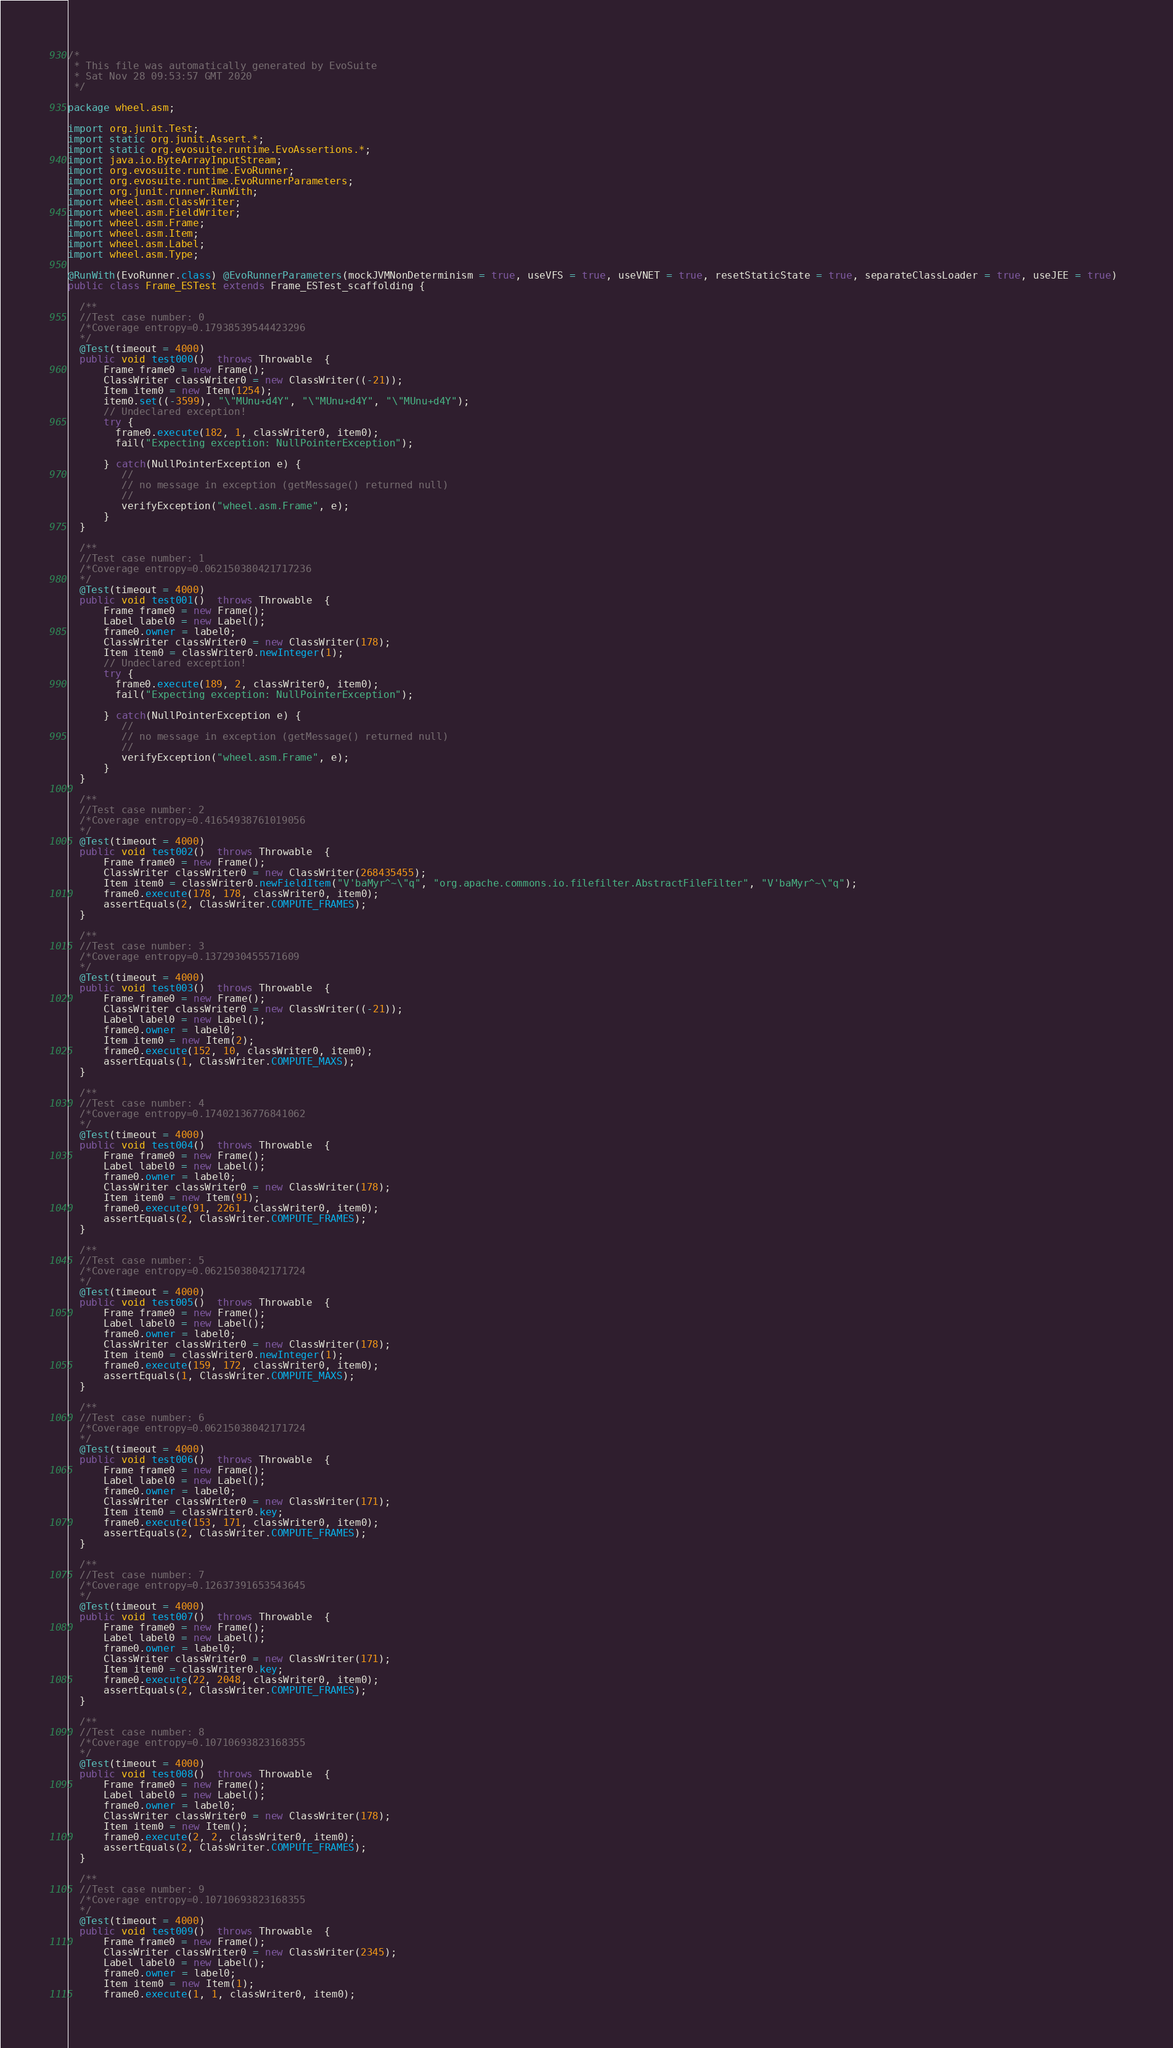<code> <loc_0><loc_0><loc_500><loc_500><_Java_>/*
 * This file was automatically generated by EvoSuite
 * Sat Nov 28 09:53:57 GMT 2020
 */

package wheel.asm;

import org.junit.Test;
import static org.junit.Assert.*;
import static org.evosuite.runtime.EvoAssertions.*;
import java.io.ByteArrayInputStream;
import org.evosuite.runtime.EvoRunner;
import org.evosuite.runtime.EvoRunnerParameters;
import org.junit.runner.RunWith;
import wheel.asm.ClassWriter;
import wheel.asm.FieldWriter;
import wheel.asm.Frame;
import wheel.asm.Item;
import wheel.asm.Label;
import wheel.asm.Type;

@RunWith(EvoRunner.class) @EvoRunnerParameters(mockJVMNonDeterminism = true, useVFS = true, useVNET = true, resetStaticState = true, separateClassLoader = true, useJEE = true) 
public class Frame_ESTest extends Frame_ESTest_scaffolding {

  /**
  //Test case number: 0
  /*Coverage entropy=0.17938539544423296
  */
  @Test(timeout = 4000)
  public void test000()  throws Throwable  {
      Frame frame0 = new Frame();
      ClassWriter classWriter0 = new ClassWriter((-21));
      Item item0 = new Item(1254);
      item0.set((-3599), "\"MUnu+d4Y", "\"MUnu+d4Y", "\"MUnu+d4Y");
      // Undeclared exception!
      try { 
        frame0.execute(182, 1, classWriter0, item0);
        fail("Expecting exception: NullPointerException");
      
      } catch(NullPointerException e) {
         //
         // no message in exception (getMessage() returned null)
         //
         verifyException("wheel.asm.Frame", e);
      }
  }

  /**
  //Test case number: 1
  /*Coverage entropy=0.062150380421717236
  */
  @Test(timeout = 4000)
  public void test001()  throws Throwable  {
      Frame frame0 = new Frame();
      Label label0 = new Label();
      frame0.owner = label0;
      ClassWriter classWriter0 = new ClassWriter(178);
      Item item0 = classWriter0.newInteger(1);
      // Undeclared exception!
      try { 
        frame0.execute(189, 2, classWriter0, item0);
        fail("Expecting exception: NullPointerException");
      
      } catch(NullPointerException e) {
         //
         // no message in exception (getMessage() returned null)
         //
         verifyException("wheel.asm.Frame", e);
      }
  }

  /**
  //Test case number: 2
  /*Coverage entropy=0.41654938761019056
  */
  @Test(timeout = 4000)
  public void test002()  throws Throwable  {
      Frame frame0 = new Frame();
      ClassWriter classWriter0 = new ClassWriter(268435455);
      Item item0 = classWriter0.newFieldItem("V'baMyr^~\"q", "org.apache.commons.io.filefilter.AbstractFileFilter", "V'baMyr^~\"q");
      frame0.execute(178, 178, classWriter0, item0);
      assertEquals(2, ClassWriter.COMPUTE_FRAMES);
  }

  /**
  //Test case number: 3
  /*Coverage entropy=0.1372930455571609
  */
  @Test(timeout = 4000)
  public void test003()  throws Throwable  {
      Frame frame0 = new Frame();
      ClassWriter classWriter0 = new ClassWriter((-21));
      Label label0 = new Label();
      frame0.owner = label0;
      Item item0 = new Item(2);
      frame0.execute(152, 10, classWriter0, item0);
      assertEquals(1, ClassWriter.COMPUTE_MAXS);
  }

  /**
  //Test case number: 4
  /*Coverage entropy=0.17402136776841062
  */
  @Test(timeout = 4000)
  public void test004()  throws Throwable  {
      Frame frame0 = new Frame();
      Label label0 = new Label();
      frame0.owner = label0;
      ClassWriter classWriter0 = new ClassWriter(178);
      Item item0 = new Item(91);
      frame0.execute(91, 2261, classWriter0, item0);
      assertEquals(2, ClassWriter.COMPUTE_FRAMES);
  }

  /**
  //Test case number: 5
  /*Coverage entropy=0.06215038042171724
  */
  @Test(timeout = 4000)
  public void test005()  throws Throwable  {
      Frame frame0 = new Frame();
      Label label0 = new Label();
      frame0.owner = label0;
      ClassWriter classWriter0 = new ClassWriter(178);
      Item item0 = classWriter0.newInteger(1);
      frame0.execute(159, 172, classWriter0, item0);
      assertEquals(1, ClassWriter.COMPUTE_MAXS);
  }

  /**
  //Test case number: 6
  /*Coverage entropy=0.06215038042171724
  */
  @Test(timeout = 4000)
  public void test006()  throws Throwable  {
      Frame frame0 = new Frame();
      Label label0 = new Label();
      frame0.owner = label0;
      ClassWriter classWriter0 = new ClassWriter(171);
      Item item0 = classWriter0.key;
      frame0.execute(153, 171, classWriter0, item0);
      assertEquals(2, ClassWriter.COMPUTE_FRAMES);
  }

  /**
  //Test case number: 7
  /*Coverage entropy=0.12637391653543645
  */
  @Test(timeout = 4000)
  public void test007()  throws Throwable  {
      Frame frame0 = new Frame();
      Label label0 = new Label();
      frame0.owner = label0;
      ClassWriter classWriter0 = new ClassWriter(171);
      Item item0 = classWriter0.key;
      frame0.execute(22, 2048, classWriter0, item0);
      assertEquals(2, ClassWriter.COMPUTE_FRAMES);
  }

  /**
  //Test case number: 8
  /*Coverage entropy=0.10710693823168355
  */
  @Test(timeout = 4000)
  public void test008()  throws Throwable  {
      Frame frame0 = new Frame();
      Label label0 = new Label();
      frame0.owner = label0;
      ClassWriter classWriter0 = new ClassWriter(178);
      Item item0 = new Item();
      frame0.execute(2, 2, classWriter0, item0);
      assertEquals(2, ClassWriter.COMPUTE_FRAMES);
  }

  /**
  //Test case number: 9
  /*Coverage entropy=0.10710693823168355
  */
  @Test(timeout = 4000)
  public void test009()  throws Throwable  {
      Frame frame0 = new Frame();
      ClassWriter classWriter0 = new ClassWriter(2345);
      Label label0 = new Label();
      frame0.owner = label0;
      Item item0 = new Item(1);
      frame0.execute(1, 1, classWriter0, item0);</code> 